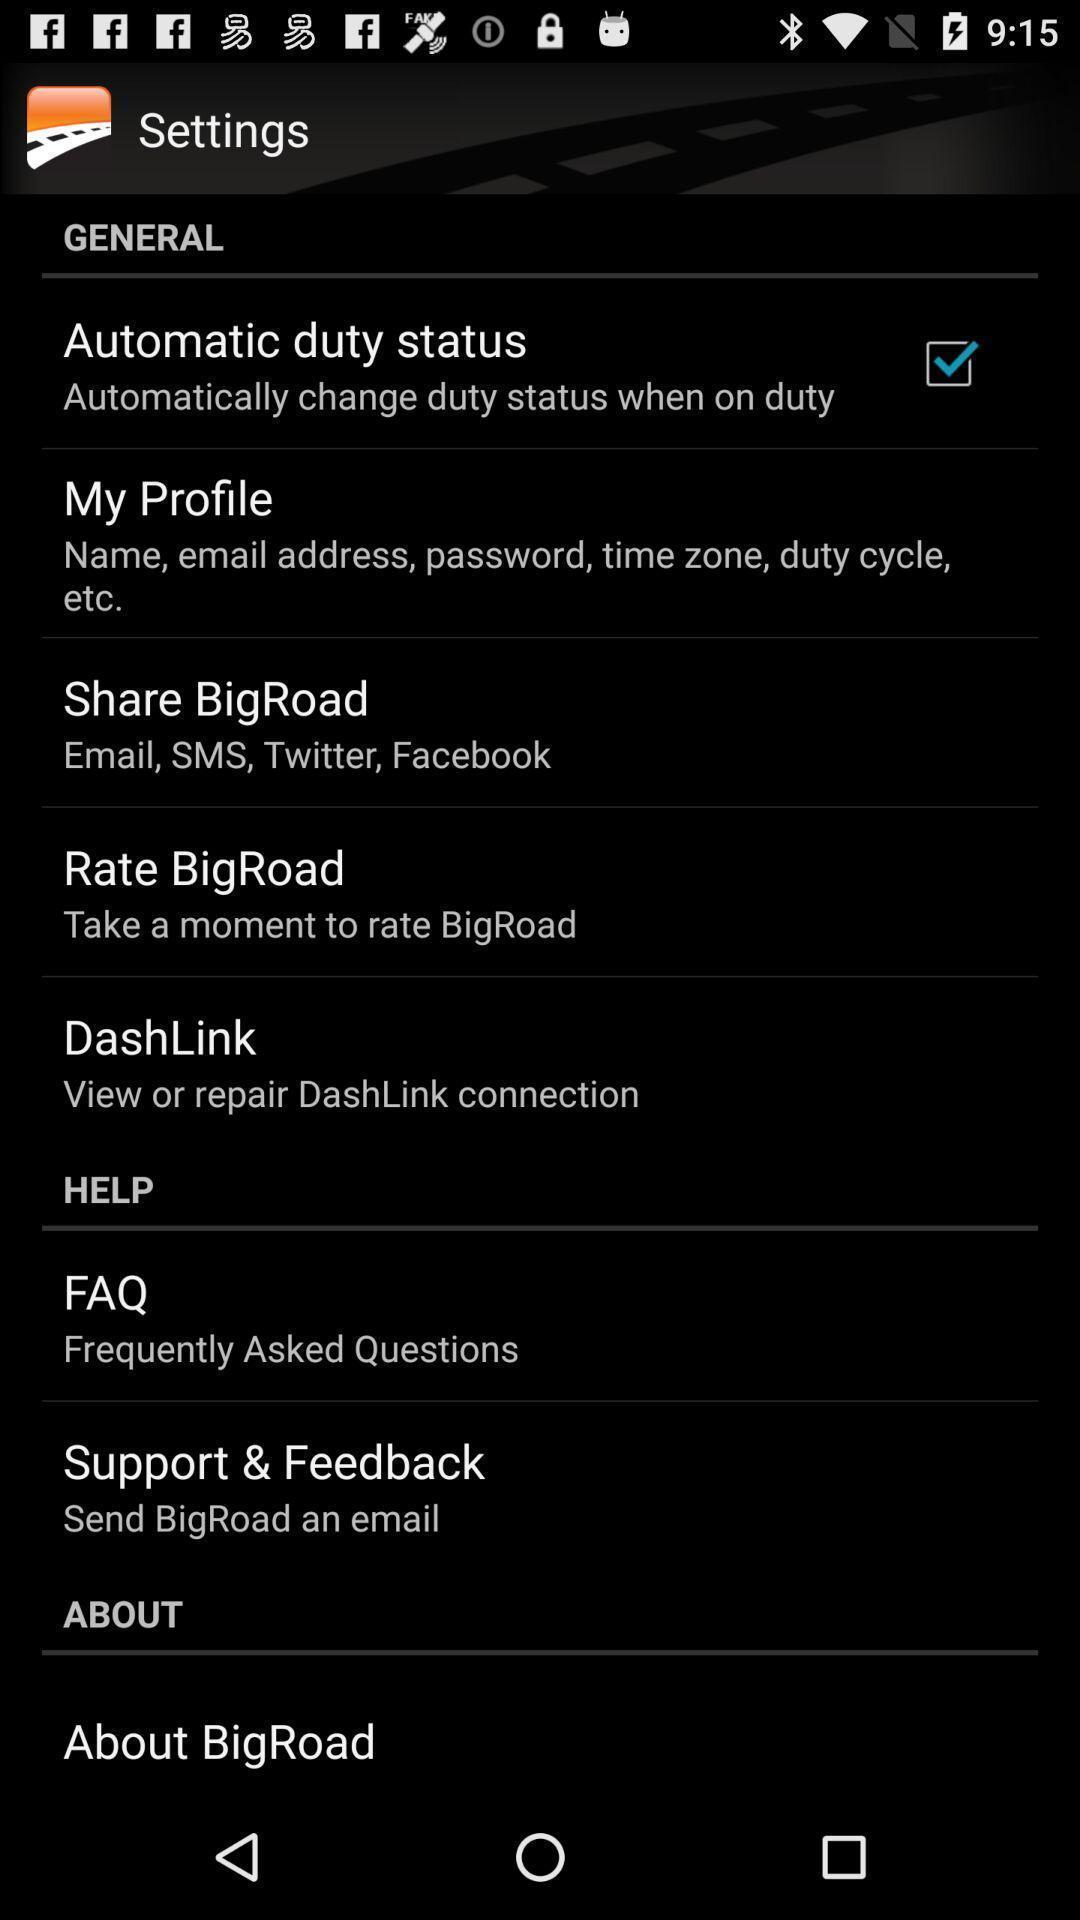Give me a summary of this screen capture. Screen displaying multiple setting options. 